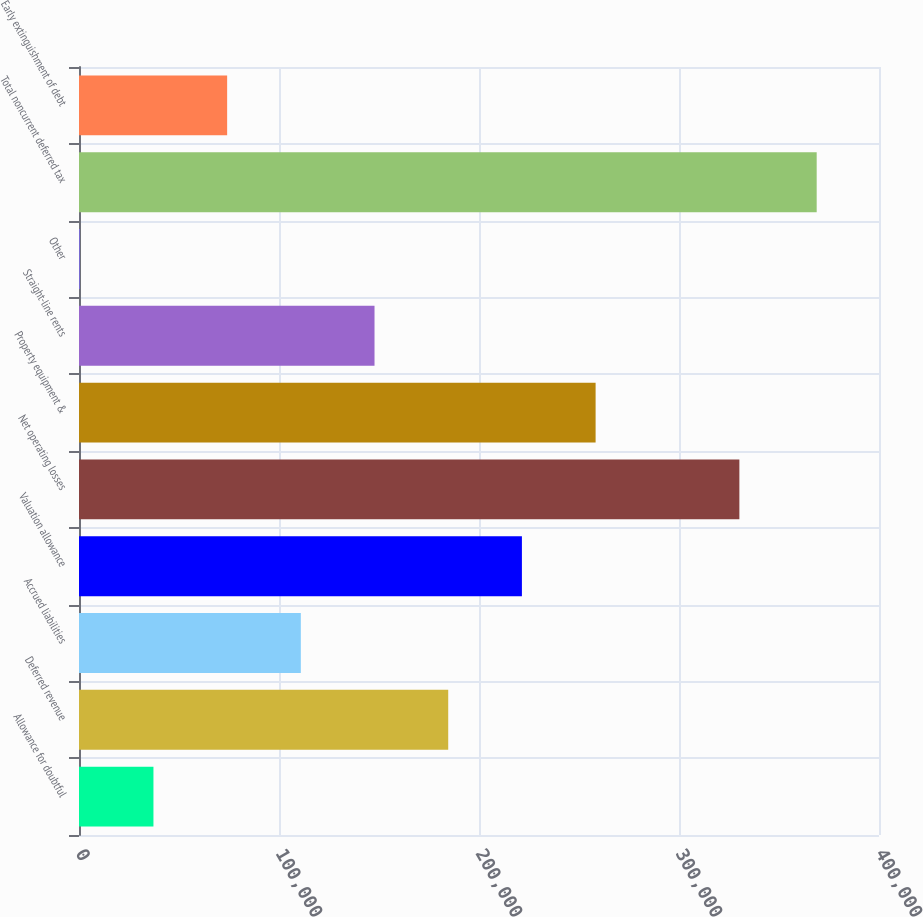Convert chart. <chart><loc_0><loc_0><loc_500><loc_500><bar_chart><fcel>Allowance for doubtful<fcel>Deferred revenue<fcel>Accrued liabilities<fcel>Valuation allowance<fcel>Net operating losses<fcel>Property equipment &<fcel>Straight-line rents<fcel>Other<fcel>Total noncurrent deferred tax<fcel>Early extinguishment of debt<nl><fcel>37222.7<fcel>184610<fcel>110916<fcel>221456<fcel>330187<fcel>258303<fcel>147763<fcel>376<fcel>368843<fcel>74069.4<nl></chart> 